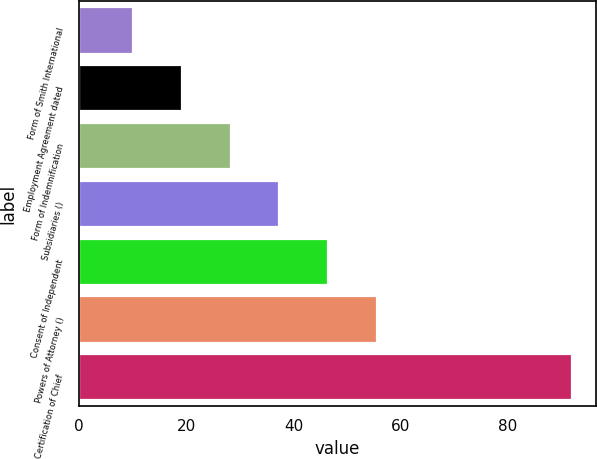Convert chart to OTSL. <chart><loc_0><loc_0><loc_500><loc_500><bar_chart><fcel>Form of Smith International<fcel>Employment Agreement dated<fcel>Form of Indemnification<fcel>Subsidiaries ()<fcel>Consent of Independent<fcel>Powers of Attorney ()<fcel>Certification of Chief<nl><fcel>10.15<fcel>19.23<fcel>28.31<fcel>37.39<fcel>46.48<fcel>55.56<fcel>91.88<nl></chart> 